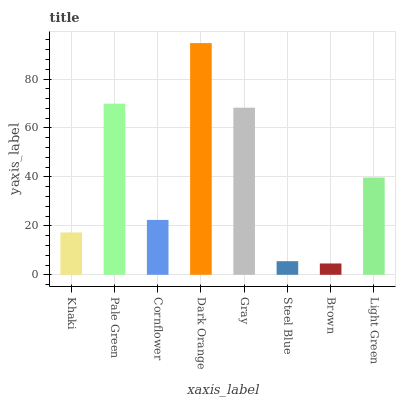Is Brown the minimum?
Answer yes or no. Yes. Is Dark Orange the maximum?
Answer yes or no. Yes. Is Pale Green the minimum?
Answer yes or no. No. Is Pale Green the maximum?
Answer yes or no. No. Is Pale Green greater than Khaki?
Answer yes or no. Yes. Is Khaki less than Pale Green?
Answer yes or no. Yes. Is Khaki greater than Pale Green?
Answer yes or no. No. Is Pale Green less than Khaki?
Answer yes or no. No. Is Light Green the high median?
Answer yes or no. Yes. Is Cornflower the low median?
Answer yes or no. Yes. Is Khaki the high median?
Answer yes or no. No. Is Khaki the low median?
Answer yes or no. No. 